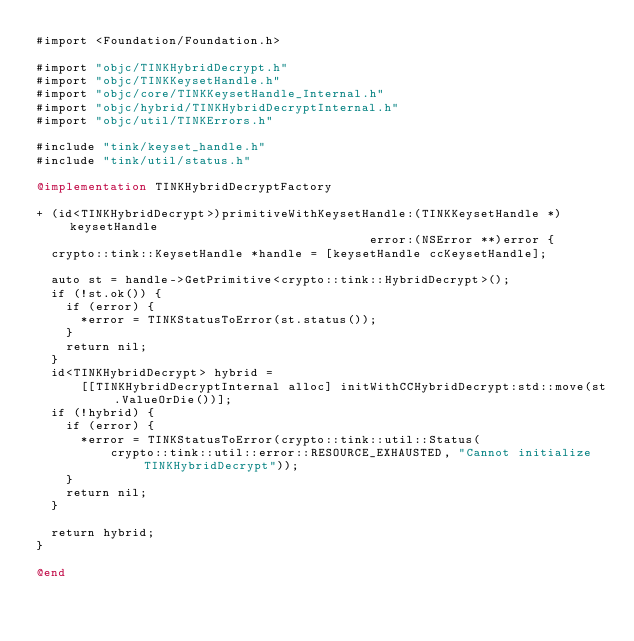<code> <loc_0><loc_0><loc_500><loc_500><_ObjectiveC_>#import <Foundation/Foundation.h>

#import "objc/TINKHybridDecrypt.h"
#import "objc/TINKKeysetHandle.h"
#import "objc/core/TINKKeysetHandle_Internal.h"
#import "objc/hybrid/TINKHybridDecryptInternal.h"
#import "objc/util/TINKErrors.h"

#include "tink/keyset_handle.h"
#include "tink/util/status.h"

@implementation TINKHybridDecryptFactory

+ (id<TINKHybridDecrypt>)primitiveWithKeysetHandle:(TINKKeysetHandle *)keysetHandle
                                             error:(NSError **)error {
  crypto::tink::KeysetHandle *handle = [keysetHandle ccKeysetHandle];

  auto st = handle->GetPrimitive<crypto::tink::HybridDecrypt>();
  if (!st.ok()) {
    if (error) {
      *error = TINKStatusToError(st.status());
    }
    return nil;
  }
  id<TINKHybridDecrypt> hybrid =
      [[TINKHybridDecryptInternal alloc] initWithCCHybridDecrypt:std::move(st.ValueOrDie())];
  if (!hybrid) {
    if (error) {
      *error = TINKStatusToError(crypto::tink::util::Status(
          crypto::tink::util::error::RESOURCE_EXHAUSTED, "Cannot initialize TINKHybridDecrypt"));
    }
    return nil;
  }

  return hybrid;
}

@end
</code> 